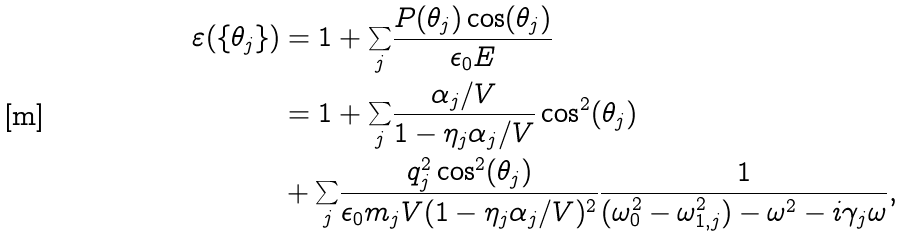<formula> <loc_0><loc_0><loc_500><loc_500>\varepsilon ( \{ \theta _ { j } \} ) & = 1 + \underset { j } { \sum } \frac { P ( \theta _ { j } ) \cos ( \theta _ { j } ) } { \epsilon _ { 0 } E } \\ & = 1 + \underset { j } { \sum } \frac { \alpha _ { j } / V } { 1 - \eta _ { j } \alpha _ { j } / V } \cos ^ { 2 } ( \theta _ { j } ) \\ & + \underset { j } { \sum } \frac { q _ { j } ^ { 2 } \cos ^ { 2 } ( \theta _ { j } ) } { \epsilon _ { 0 } m _ { j } V ( 1 - \eta _ { j } \alpha _ { j } / V ) ^ { 2 } } \frac { 1 } { ( \omega _ { 0 } ^ { 2 } - \omega _ { 1 , j } ^ { 2 } ) - \omega ^ { 2 } - i \gamma _ { j } \omega } ,</formula> 